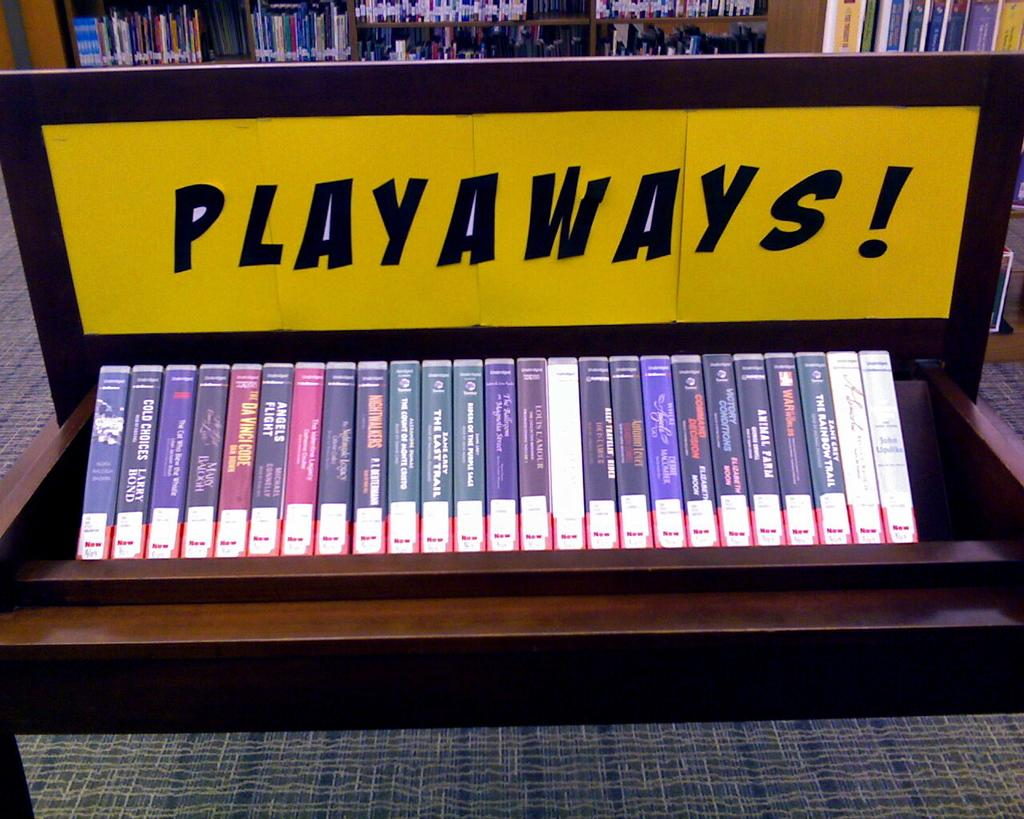<image>
Relay a brief, clear account of the picture shown. A collection of videos on display are under a sign that says PLAYAWAYS. 